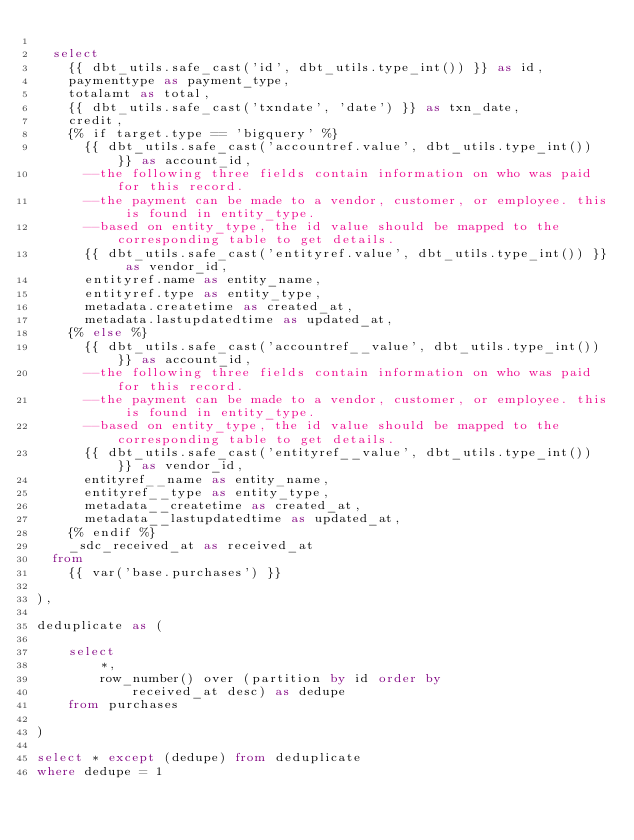Convert code to text. <code><loc_0><loc_0><loc_500><loc_500><_SQL_>
  select
    {{ dbt_utils.safe_cast('id', dbt_utils.type_int()) }} as id,
    paymenttype as payment_type,
    totalamt as total,
    {{ dbt_utils.safe_cast('txndate', 'date') }} as txn_date,
    credit,
    {% if target.type == 'bigquery' %}
      {{ dbt_utils.safe_cast('accountref.value', dbt_utils.type_int()) }} as account_id,
      --the following three fields contain information on who was paid for this record.
      --the payment can be made to a vendor, customer, or employee. this is found in entity_type.
      --based on entity_type, the id value should be mapped to the corresponding table to get details.
      {{ dbt_utils.safe_cast('entityref.value', dbt_utils.type_int()) }} as vendor_id,
      entityref.name as entity_name,
      entityref.type as entity_type,
      metadata.createtime as created_at,
      metadata.lastupdatedtime as updated_at,
    {% else %}
      {{ dbt_utils.safe_cast('accountref__value', dbt_utils.type_int()) }} as account_id,
      --the following three fields contain information on who was paid for this record.
      --the payment can be made to a vendor, customer, or employee. this is found in entity_type.
      --based on entity_type, the id value should be mapped to the corresponding table to get details.
      {{ dbt_utils.safe_cast('entityref__value', dbt_utils.type_int()) }} as vendor_id,
      entityref__name as entity_name,
      entityref__type as entity_type,
      metadata__createtime as created_at,
      metadata__lastupdatedtime as updated_at,
    {% endif %}
    _sdc_received_at as received_at
  from
    {{ var('base.purchases') }}

),

deduplicate as (

    select
        *,
        row_number() over (partition by id order by
            received_at desc) as dedupe
    from purchases

)

select * except (dedupe) from deduplicate
where dedupe = 1
</code> 